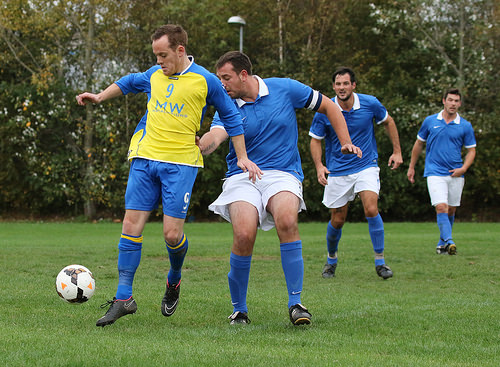<image>
Can you confirm if the shirt is on the man? No. The shirt is not positioned on the man. They may be near each other, but the shirt is not supported by or resting on top of the man. 